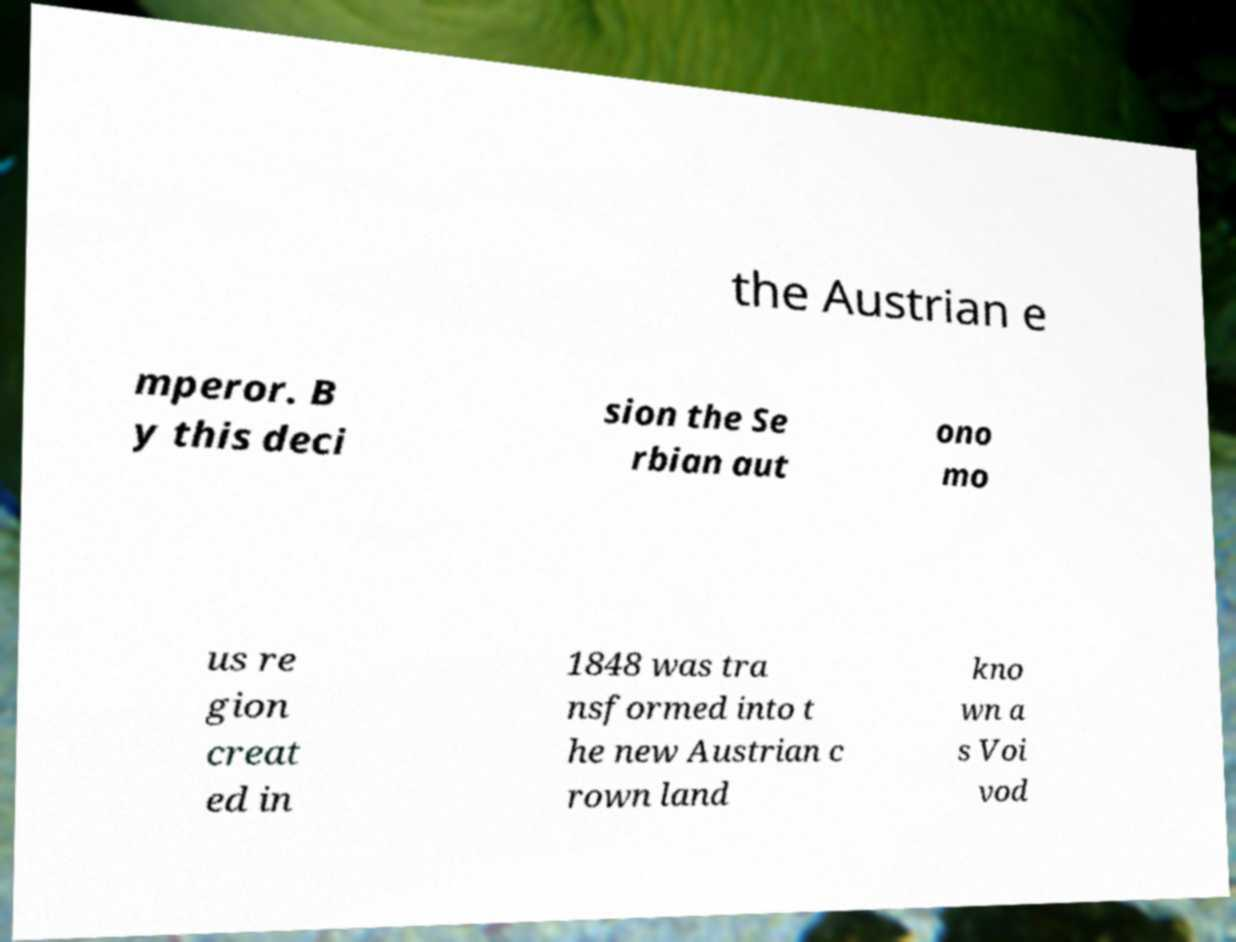Could you assist in decoding the text presented in this image and type it out clearly? the Austrian e mperor. B y this deci sion the Se rbian aut ono mo us re gion creat ed in 1848 was tra nsformed into t he new Austrian c rown land kno wn a s Voi vod 